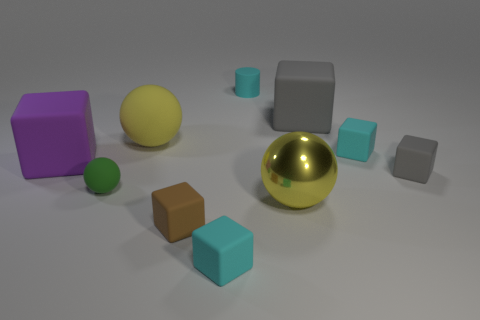How does the texture of the golden sphere compare to the textures of the other objects in the image? The golden sphere has a highly reflective and smooth texture, which sets it apart from the others. Most objects display a matte finish, while the golden sphere's shiny surface catches light and clearly reflects the environment, giving it a distinctive and luxurious appearance. 